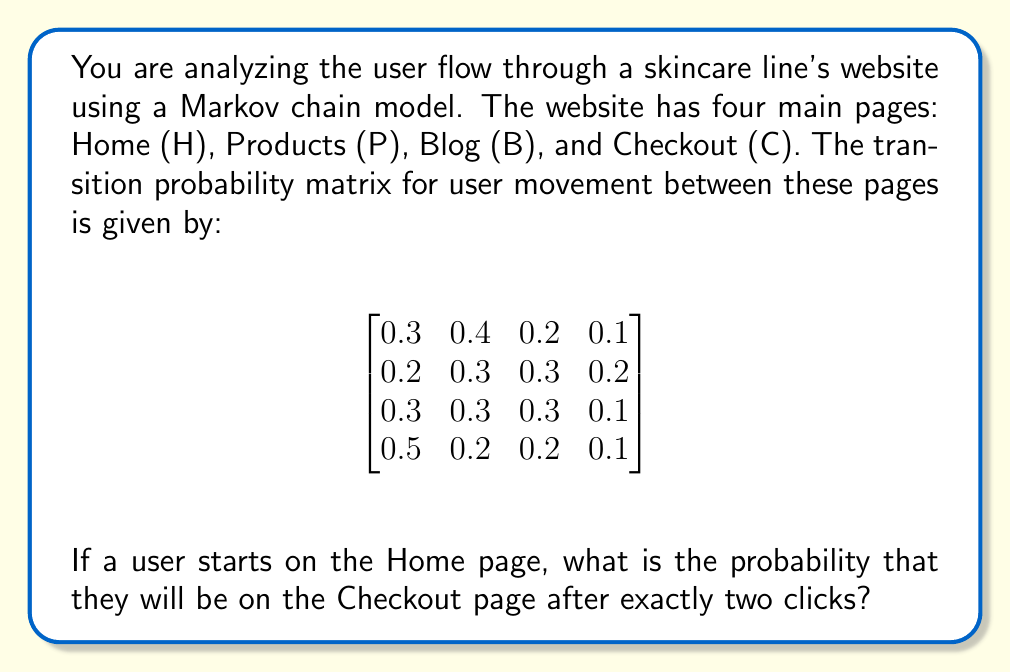Can you answer this question? To solve this problem, we need to use the properties of Markov chains and matrix multiplication. Let's break it down step-by-step:

1. The given matrix represents the transition probabilities between pages, where each row corresponds to the starting page and each column to the destination page. The order is [H, P, B, C].

2. We want to find the probability of being on the Checkout page (C) after two clicks, starting from the Home page (H).

3. To calculate this, we need to multiply the transition matrix by itself once, and then look at the element in the first row (Home) and fourth column (Checkout) of the resulting matrix.

4. Let's call our transition matrix $P$. We need to calculate $P^2$:

   $$P^2 = P \times P = \begin{bmatrix}
   0.3 & 0.4 & 0.2 & 0.1 \\
   0.2 & 0.3 & 0.3 & 0.2 \\
   0.3 & 0.3 & 0.3 & 0.1 \\
   0.5 & 0.2 & 0.2 & 0.1
   \end{bmatrix} \times \begin{bmatrix}
   0.3 & 0.4 & 0.2 & 0.1 \\
   0.2 & 0.3 & 0.3 & 0.2 \\
   0.3 & 0.3 & 0.3 & 0.1 \\
   0.5 & 0.2 & 0.2 & 0.1
   \end{bmatrix}$$

5. Performing the matrix multiplication:

   $$P^2 = \begin{bmatrix}
   0.28 & 0.33 & 0.26 & 0.13 \\
   0.29 & 0.31 & 0.27 & 0.13 \\
   0.28 & 0.33 & 0.26 & 0.13 \\
   0.31 & 0.35 & 0.23 & 0.11
   \end{bmatrix}$$

6. The probability we're looking for is the element in the first row and fourth column of $P^2$, which is 0.13.

This means that if a user starts on the Home page, the probability of being on the Checkout page after exactly two clicks is 0.13 or 13%.
Answer: 0.13 (or 13%) 